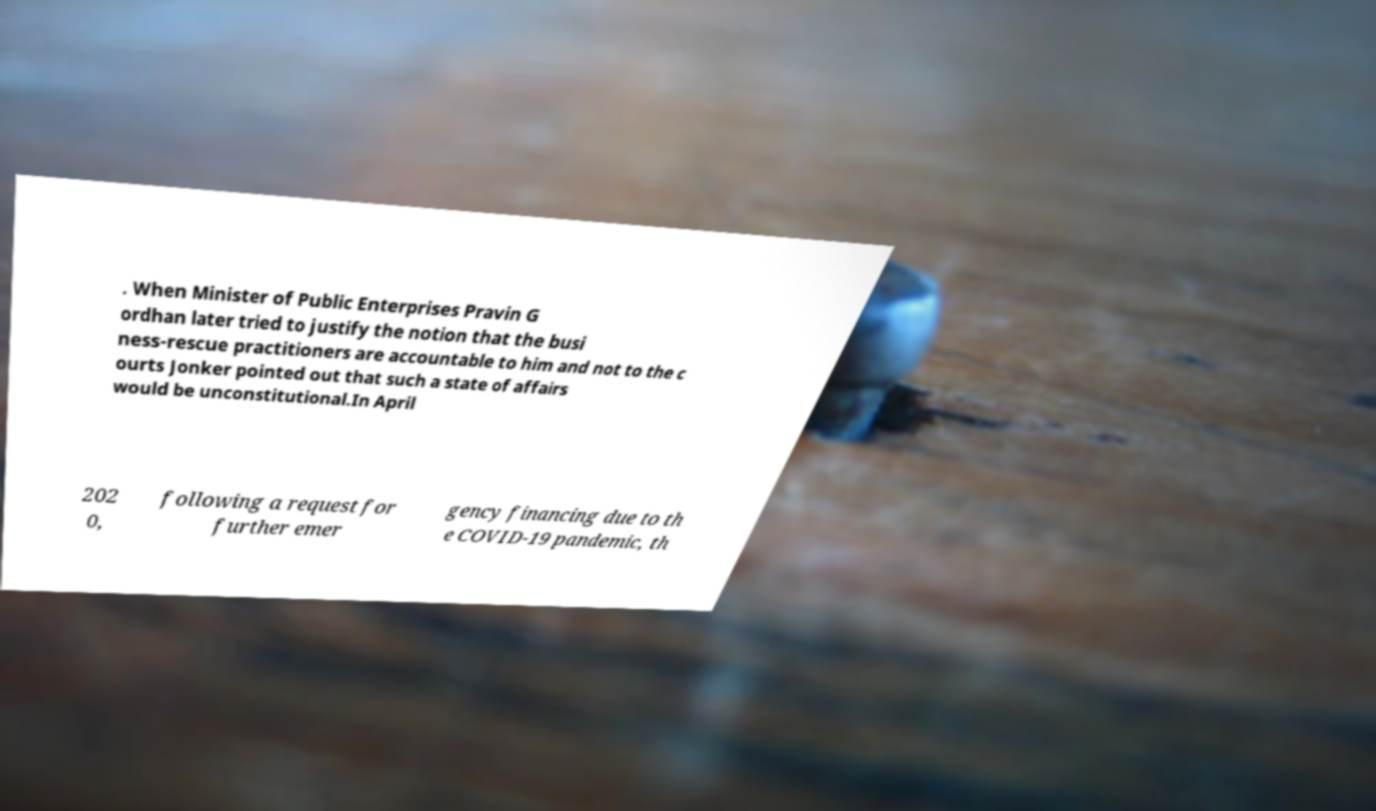For documentation purposes, I need the text within this image transcribed. Could you provide that? . When Minister of Public Enterprises Pravin G ordhan later tried to justify the notion that the busi ness-rescue practitioners are accountable to him and not to the c ourts Jonker pointed out that such a state of affairs would be unconstitutional.In April 202 0, following a request for further emer gency financing due to th e COVID-19 pandemic, th 